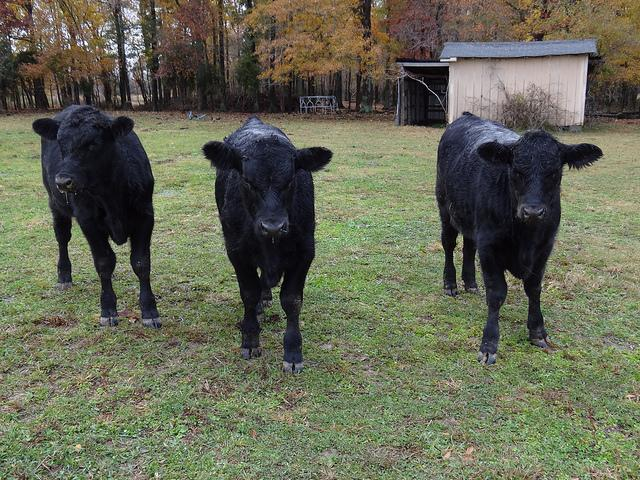How many cows are standing in the pasture field?

Choices:
A) five
B) two
C) three
D) four three 